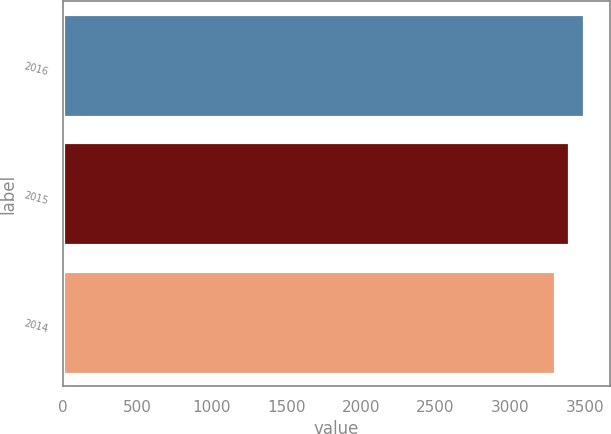<chart> <loc_0><loc_0><loc_500><loc_500><bar_chart><fcel>2016<fcel>2015<fcel>2014<nl><fcel>3493.1<fcel>3394.8<fcel>3297.6<nl></chart> 